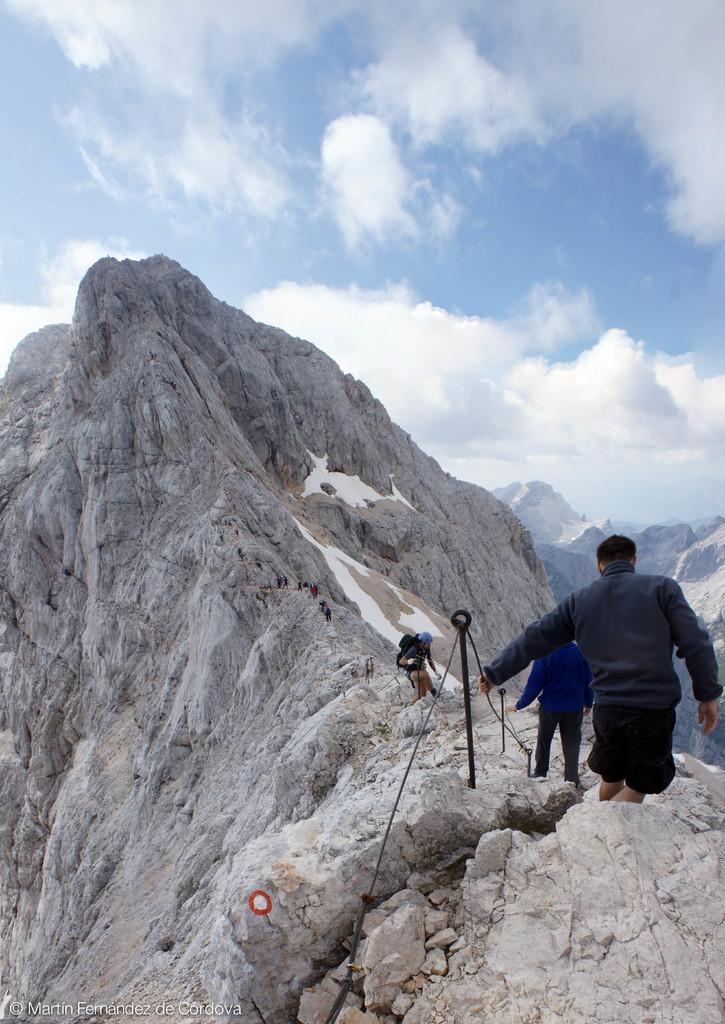Describe this image in one or two sentences. In this picture there are three persons, among them one person carrying a bag and wore a helmet. We can see poles, ropes and hills. In the background of the image we can see the sky with clouds. 